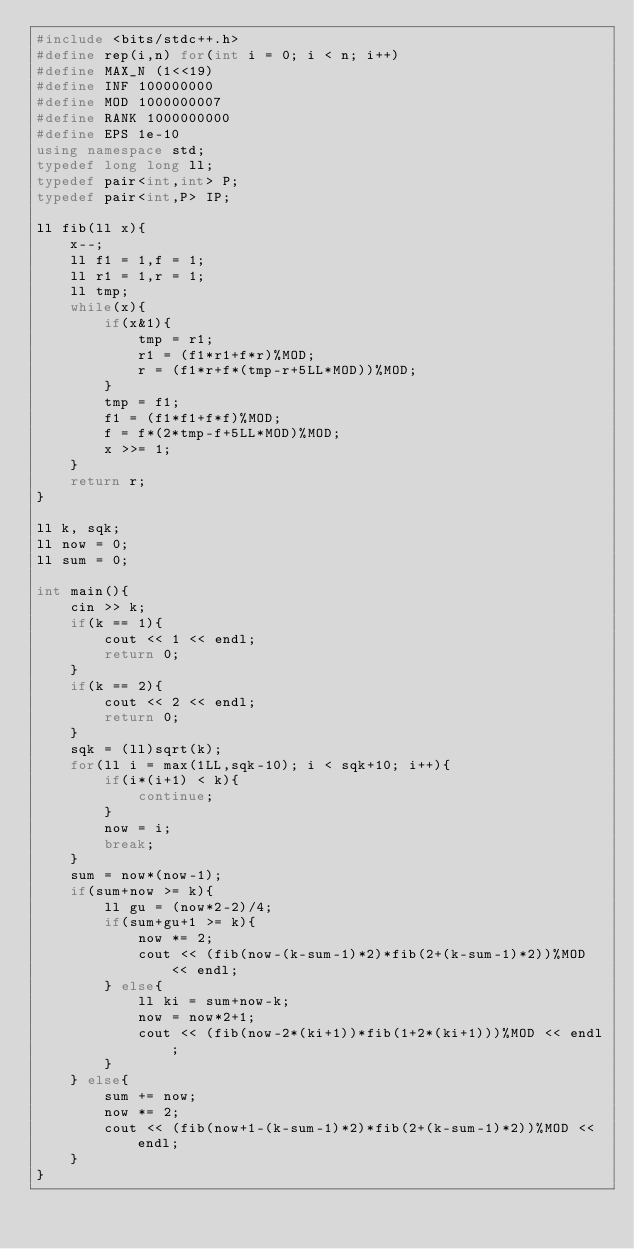<code> <loc_0><loc_0><loc_500><loc_500><_C++_>#include <bits/stdc++.h>
#define rep(i,n) for(int i = 0; i < n; i++)
#define MAX_N (1<<19)
#define INF 100000000
#define MOD 1000000007
#define RANK 1000000000
#define EPS 1e-10
using namespace std;
typedef long long ll;
typedef pair<int,int> P;
typedef pair<int,P> IP;

ll fib(ll x){
    x--;
    ll f1 = 1,f = 1;
    ll r1 = 1,r = 1;
    ll tmp;
    while(x){
        if(x&1){
            tmp = r1;
            r1 = (f1*r1+f*r)%MOD;
            r = (f1*r+f*(tmp-r+5LL*MOD))%MOD;
        }
        tmp = f1;
        f1 = (f1*f1+f*f)%MOD;
        f = f*(2*tmp-f+5LL*MOD)%MOD;
        x >>= 1;
    }
    return r;
}

ll k, sqk;
ll now = 0;
ll sum = 0;

int main(){
    cin >> k;
    if(k == 1){
        cout << 1 << endl;
        return 0;
    }
    if(k == 2){
        cout << 2 << endl;
        return 0;
    }
    sqk = (ll)sqrt(k);
    for(ll i = max(1LL,sqk-10); i < sqk+10; i++){
        if(i*(i+1) < k){
            continue;
        }
        now = i;
        break;
    }
    sum = now*(now-1);
    if(sum+now >= k){
        ll gu = (now*2-2)/4;
        if(sum+gu+1 >= k){
            now *= 2;
            cout << (fib(now-(k-sum-1)*2)*fib(2+(k-sum-1)*2))%MOD << endl;
        } else{
            ll ki = sum+now-k;
            now = now*2+1;
            cout << (fib(now-2*(ki+1))*fib(1+2*(ki+1)))%MOD << endl;
        }
    } else{
        sum += now;
        now *= 2;
        cout << (fib(now+1-(k-sum-1)*2)*fib(2+(k-sum-1)*2))%MOD << endl;
    }
}</code> 